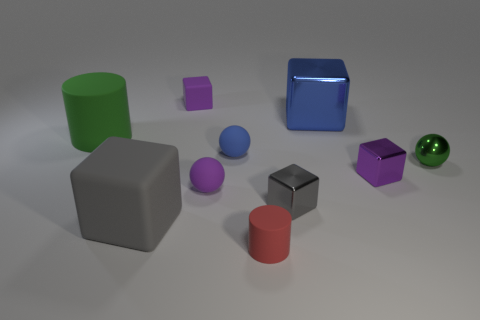Subtract all purple cubes. How many cubes are left? 3 Subtract all tiny gray cubes. How many cubes are left? 4 Subtract 2 blocks. How many blocks are left? 3 Subtract all yellow blocks. Subtract all brown cylinders. How many blocks are left? 5 Subtract all cylinders. How many objects are left? 8 Add 4 tiny red rubber cylinders. How many tiny red rubber cylinders exist? 5 Subtract 0 cyan balls. How many objects are left? 10 Subtract all tiny blue matte things. Subtract all large metal cubes. How many objects are left? 8 Add 1 green balls. How many green balls are left? 2 